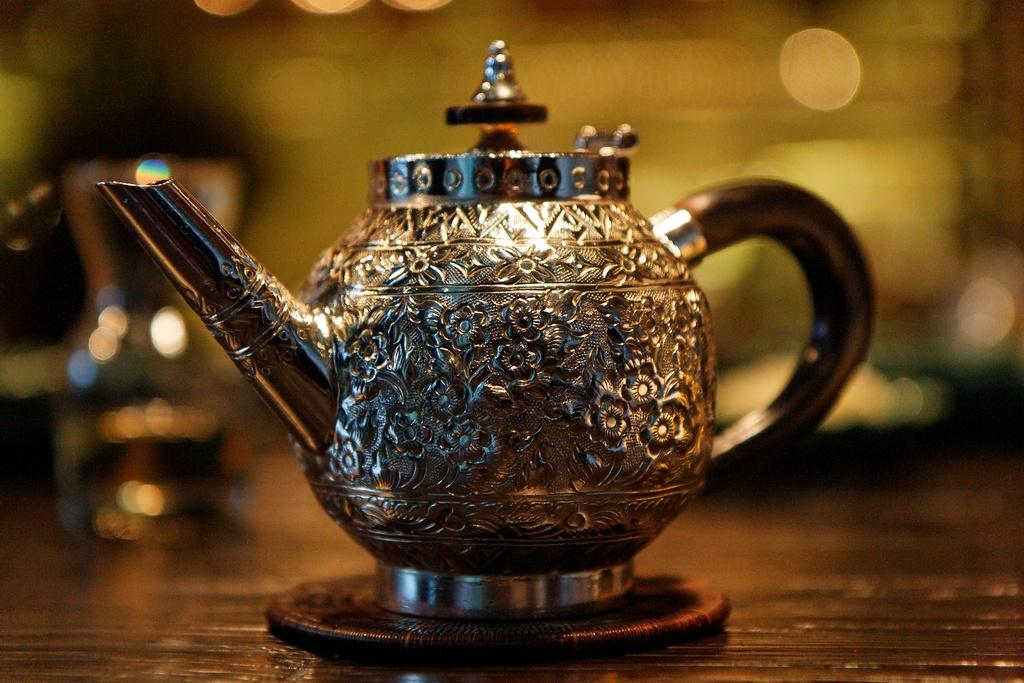What is the main object in the image? There is a kettle in the image. Where is the kettle located? The kettle is on a platform. Can you describe the background of the image? The background of the image is blurry. What type of island can be seen in the background of the image? There is no island present in the image; the background is blurry. How much money is visible in the image? There is no money present in the image. 